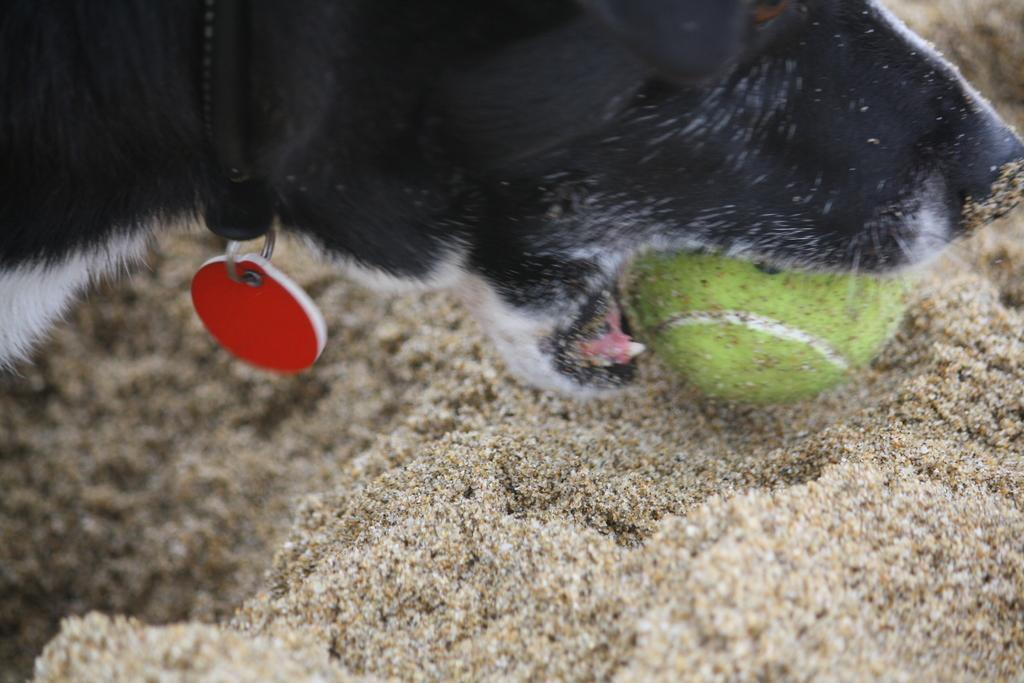What type of animal is in the image? There is a black and white dog in the image. What accessories is the dog wearing? The dog is wearing a belt and locket. What is the dog holding in its mouth? The dog is holding a ball in its mouth. What is the background of the image made of? The background of the image consists of sand. What type of drink is the dog holding in its hand? The dog is not holding a drink in its hand; it is holding a ball in its mouth. 